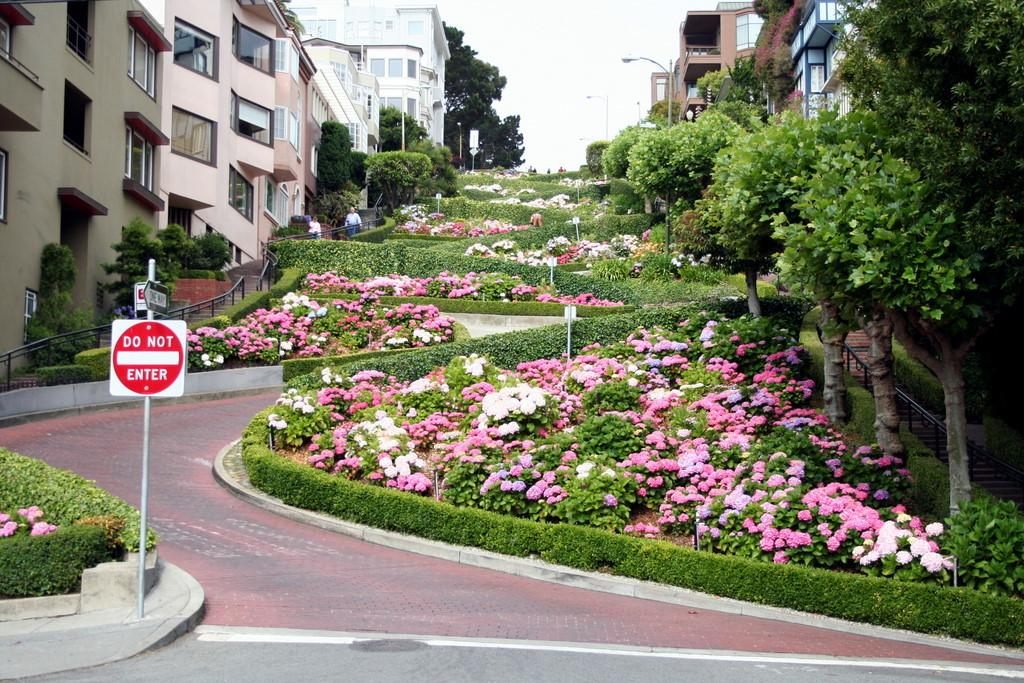What type of structures can be seen in the image? There are sign boards, flower plants, trees, a fence, a road, and buildings visible in the image. What can be found in the background of the image? The sky is visible in the background of the image. What type of vegetation is present in the image? There are flower plants and trees in the image. Can you tell me how many umbrellas are being used to plough the field in the image? There are no umbrellas or fields being ploughed present in the image. What type of notebook is being used to take notes about the scene in the image? There is no notebook present in the image, and no one is taking notes about the scene. 